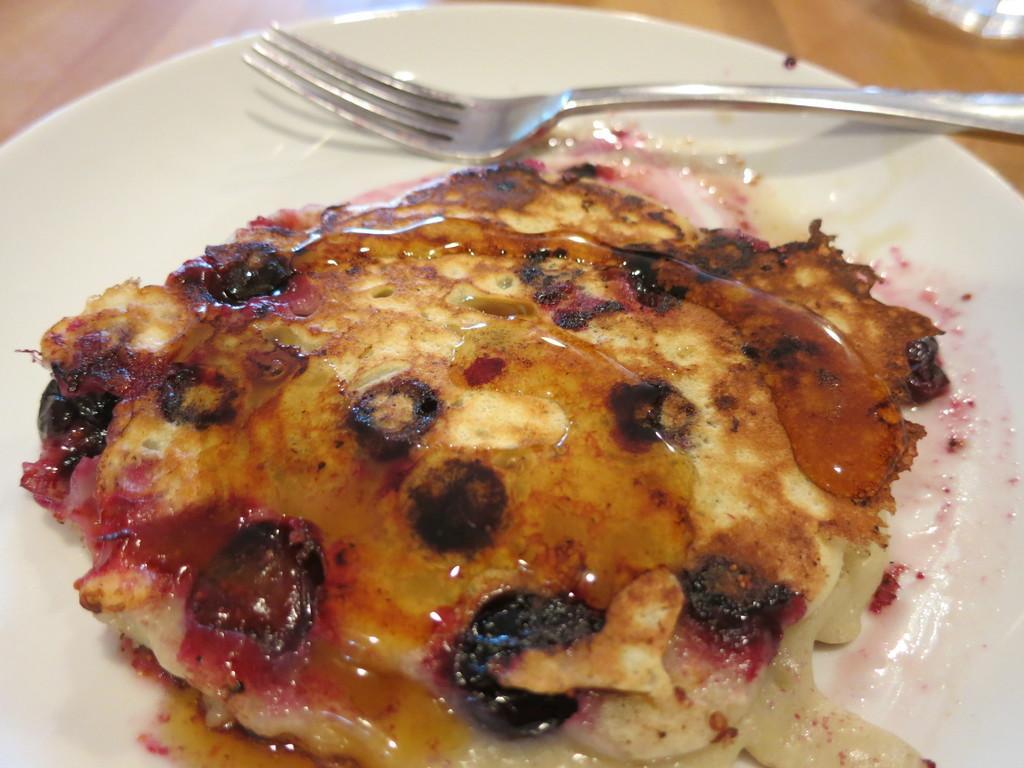In one or two sentences, can you explain what this image depicts? In this picture we can see a wooden platform. We can see food and fork on a plate. 